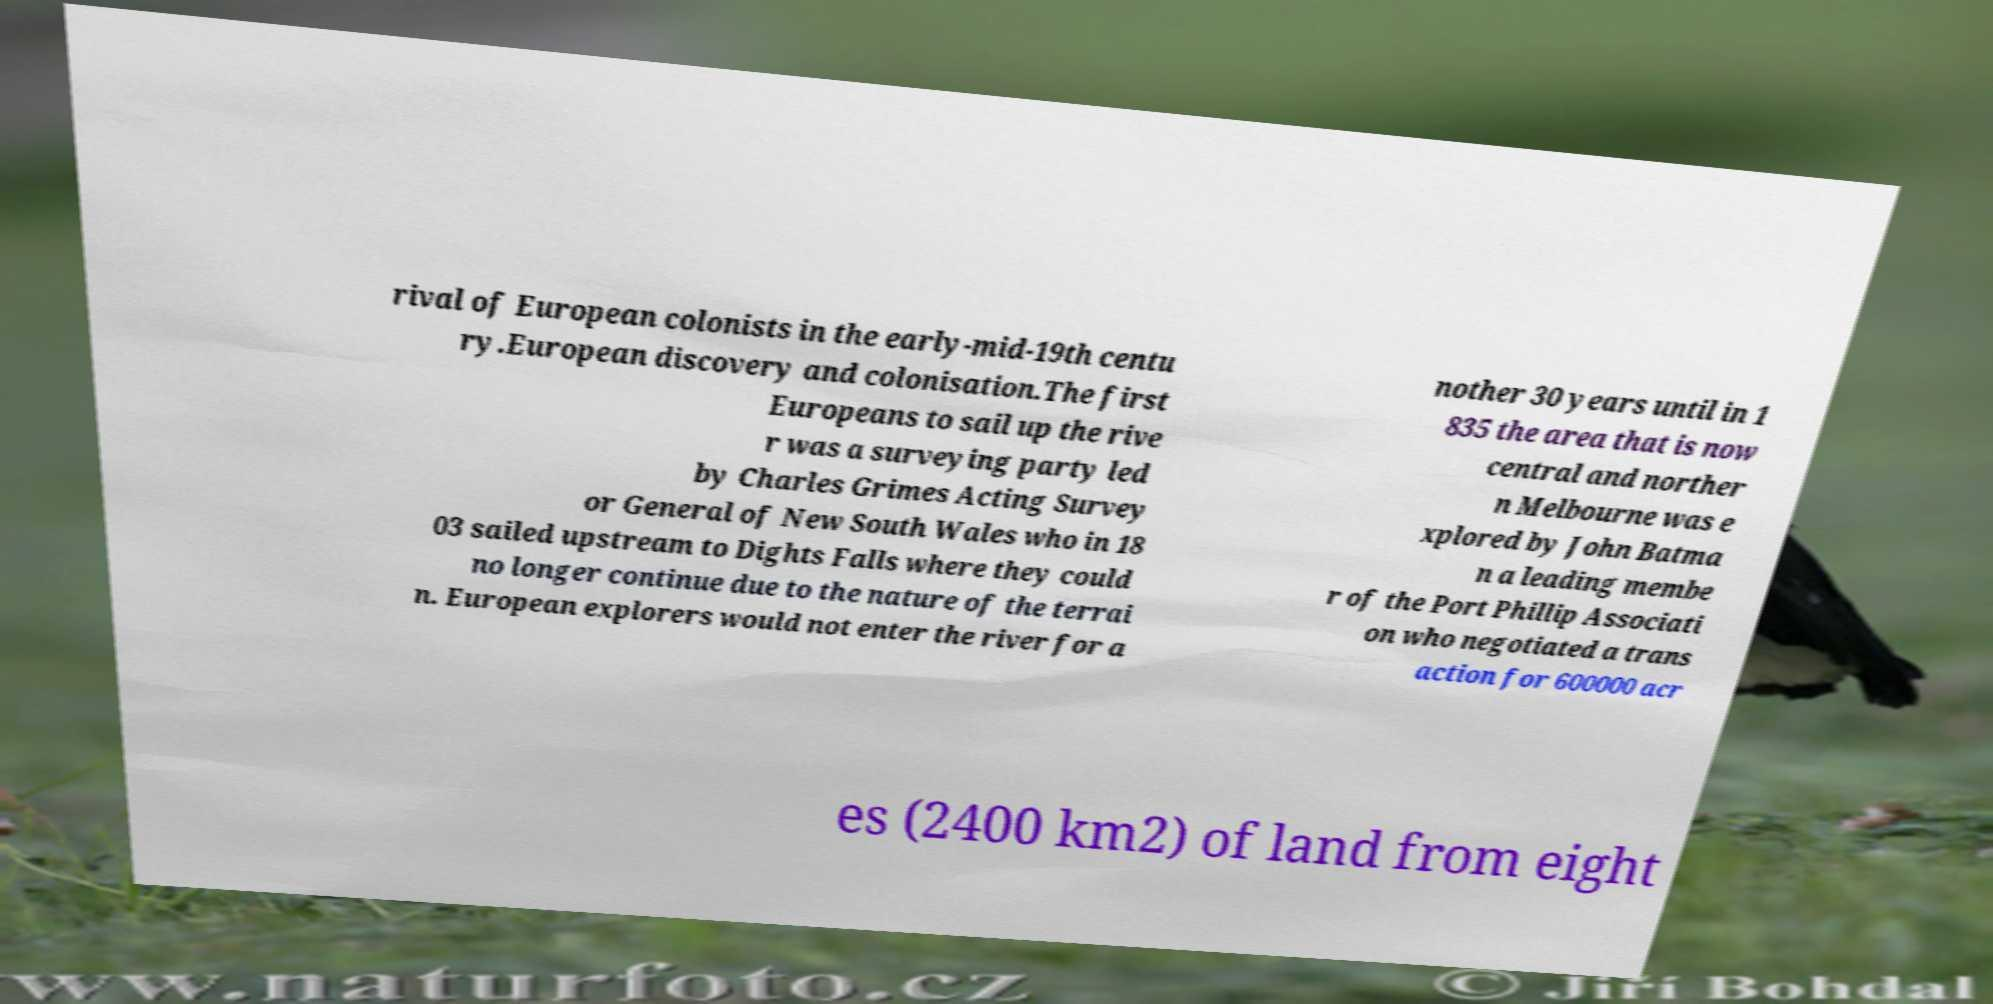I need the written content from this picture converted into text. Can you do that? rival of European colonists in the early-mid-19th centu ry.European discovery and colonisation.The first Europeans to sail up the rive r was a surveying party led by Charles Grimes Acting Survey or General of New South Wales who in 18 03 sailed upstream to Dights Falls where they could no longer continue due to the nature of the terrai n. European explorers would not enter the river for a nother 30 years until in 1 835 the area that is now central and norther n Melbourne was e xplored by John Batma n a leading membe r of the Port Phillip Associati on who negotiated a trans action for 600000 acr es (2400 km2) of land from eight 